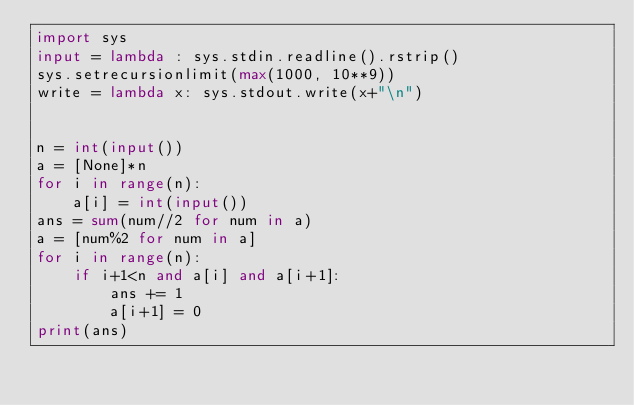Convert code to text. <code><loc_0><loc_0><loc_500><loc_500><_Python_>import sys
input = lambda : sys.stdin.readline().rstrip()
sys.setrecursionlimit(max(1000, 10**9))
write = lambda x: sys.stdout.write(x+"\n")


n = int(input())
a = [None]*n
for i in range(n):
    a[i] = int(input())
ans = sum(num//2 for num in a)
a = [num%2 for num in a]
for i in range(n):
    if i+1<n and a[i] and a[i+1]:
        ans += 1
        a[i+1] = 0
print(ans)</code> 